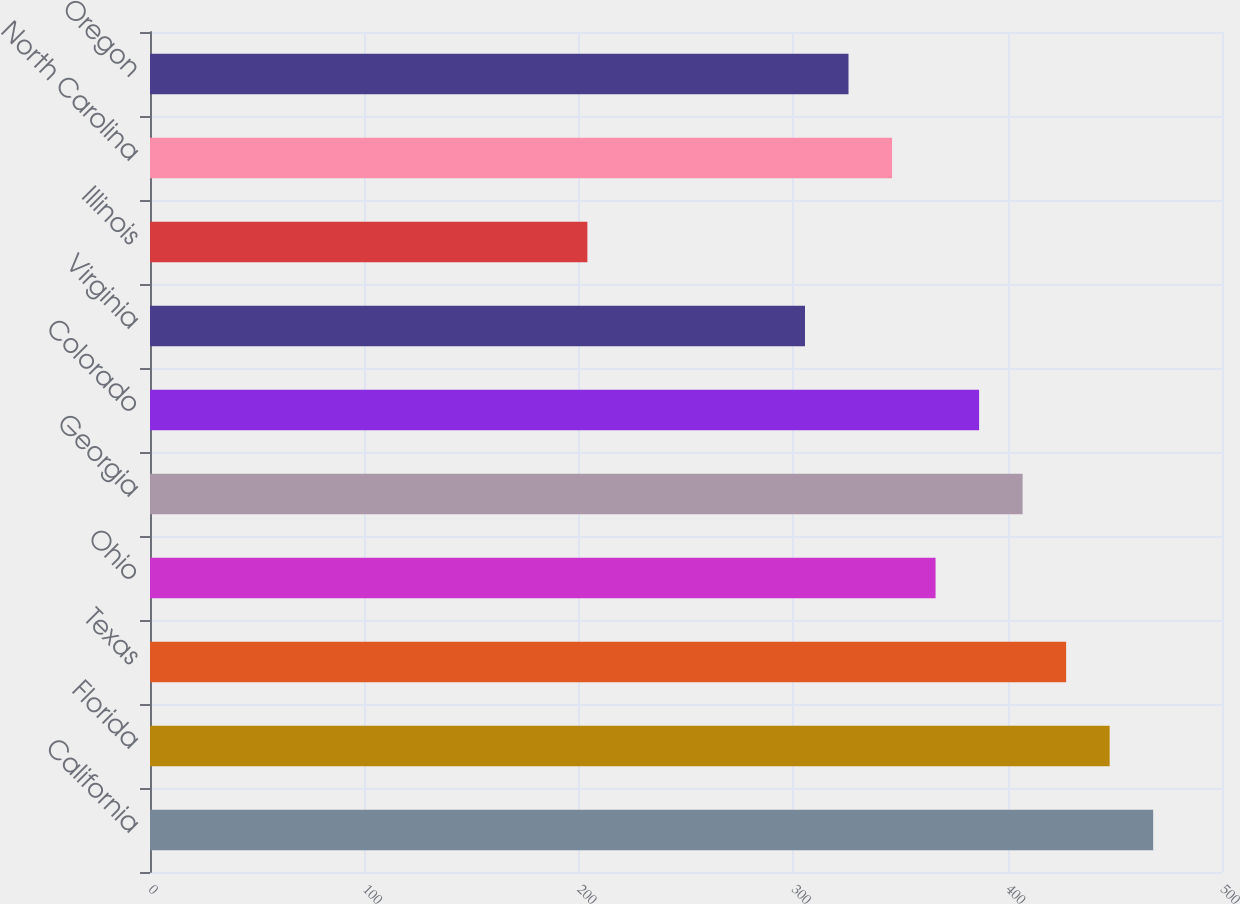<chart> <loc_0><loc_0><loc_500><loc_500><bar_chart><fcel>California<fcel>Florida<fcel>Texas<fcel>Ohio<fcel>Georgia<fcel>Colorado<fcel>Virginia<fcel>Illinois<fcel>North Carolina<fcel>Oregon<nl><fcel>467.9<fcel>447.6<fcel>427.3<fcel>366.4<fcel>407<fcel>386.7<fcel>305.5<fcel>204<fcel>346.1<fcel>325.8<nl></chart> 